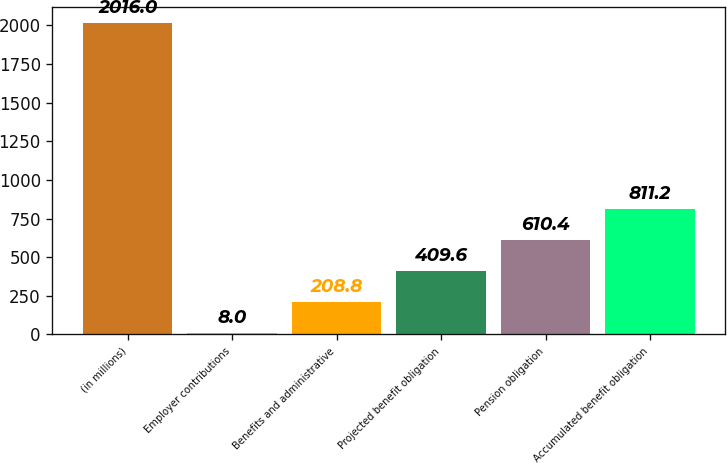Convert chart. <chart><loc_0><loc_0><loc_500><loc_500><bar_chart><fcel>(in millions)<fcel>Employer contributions<fcel>Benefits and administrative<fcel>Projected benefit obligation<fcel>Pension obligation<fcel>Accumulated benefit obligation<nl><fcel>2016<fcel>8<fcel>208.8<fcel>409.6<fcel>610.4<fcel>811.2<nl></chart> 